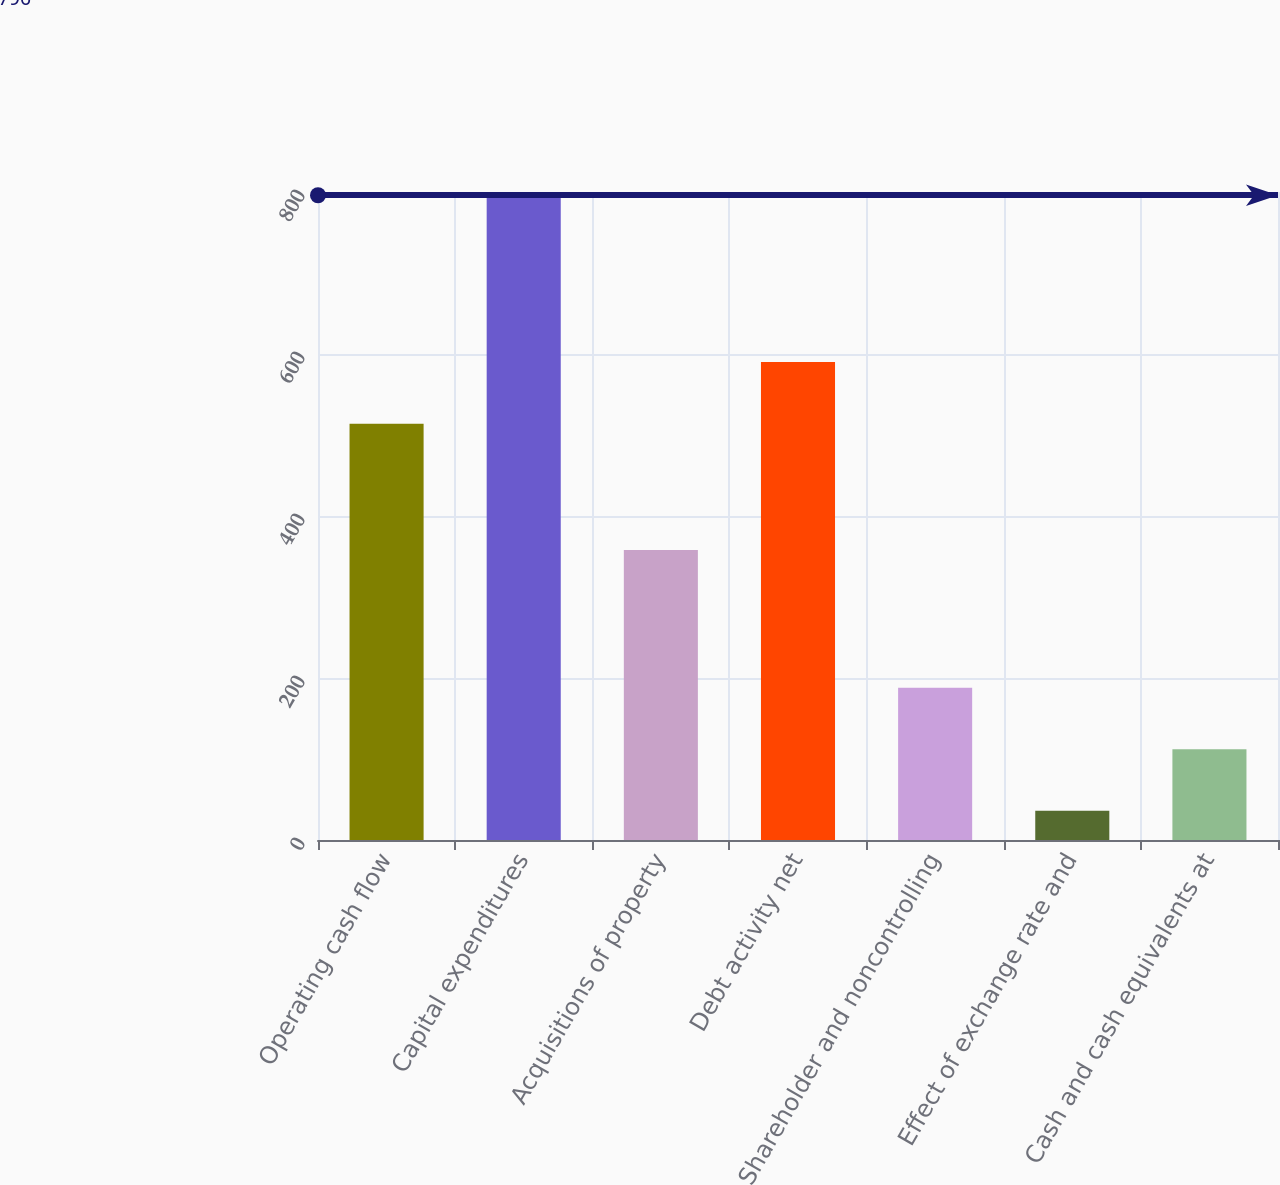<chart> <loc_0><loc_0><loc_500><loc_500><bar_chart><fcel>Operating cash flow<fcel>Capital expenditures<fcel>Acquisitions of property<fcel>Debt activity net<fcel>Shareholder and noncontrolling<fcel>Effect of exchange rate and<fcel>Cash and cash equivalents at<nl><fcel>514<fcel>796<fcel>358<fcel>590<fcel>188<fcel>36<fcel>112<nl></chart> 